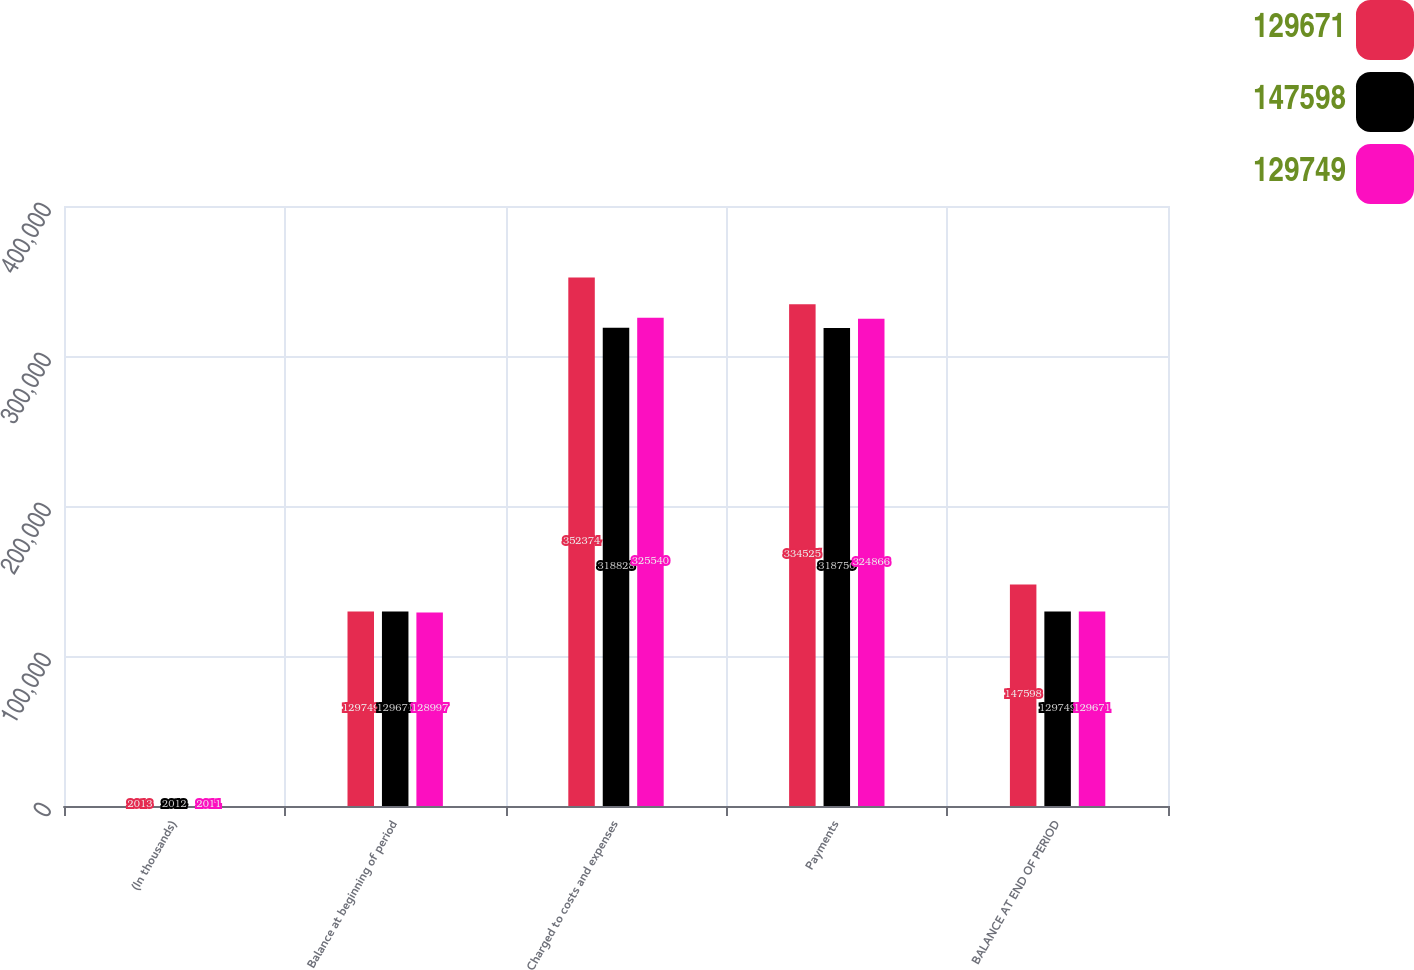Convert chart to OTSL. <chart><loc_0><loc_0><loc_500><loc_500><stacked_bar_chart><ecel><fcel>(In thousands)<fcel>Balance at beginning of period<fcel>Charged to costs and expenses<fcel>Payments<fcel>BALANCE AT END OF PERIOD<nl><fcel>129671<fcel>2013<fcel>129749<fcel>352374<fcel>334525<fcel>147598<nl><fcel>147598<fcel>2012<fcel>129671<fcel>318828<fcel>318750<fcel>129749<nl><fcel>129749<fcel>2011<fcel>128997<fcel>325540<fcel>324866<fcel>129671<nl></chart> 